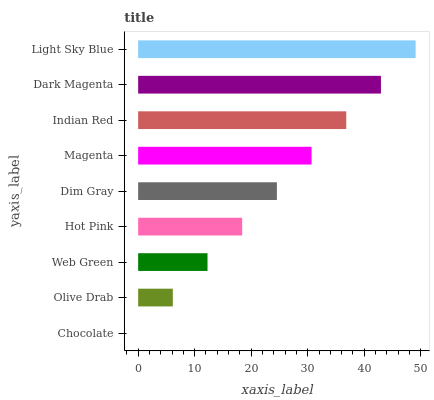Is Chocolate the minimum?
Answer yes or no. Yes. Is Light Sky Blue the maximum?
Answer yes or no. Yes. Is Olive Drab the minimum?
Answer yes or no. No. Is Olive Drab the maximum?
Answer yes or no. No. Is Olive Drab greater than Chocolate?
Answer yes or no. Yes. Is Chocolate less than Olive Drab?
Answer yes or no. Yes. Is Chocolate greater than Olive Drab?
Answer yes or no. No. Is Olive Drab less than Chocolate?
Answer yes or no. No. Is Dim Gray the high median?
Answer yes or no. Yes. Is Dim Gray the low median?
Answer yes or no. Yes. Is Olive Drab the high median?
Answer yes or no. No. Is Magenta the low median?
Answer yes or no. No. 